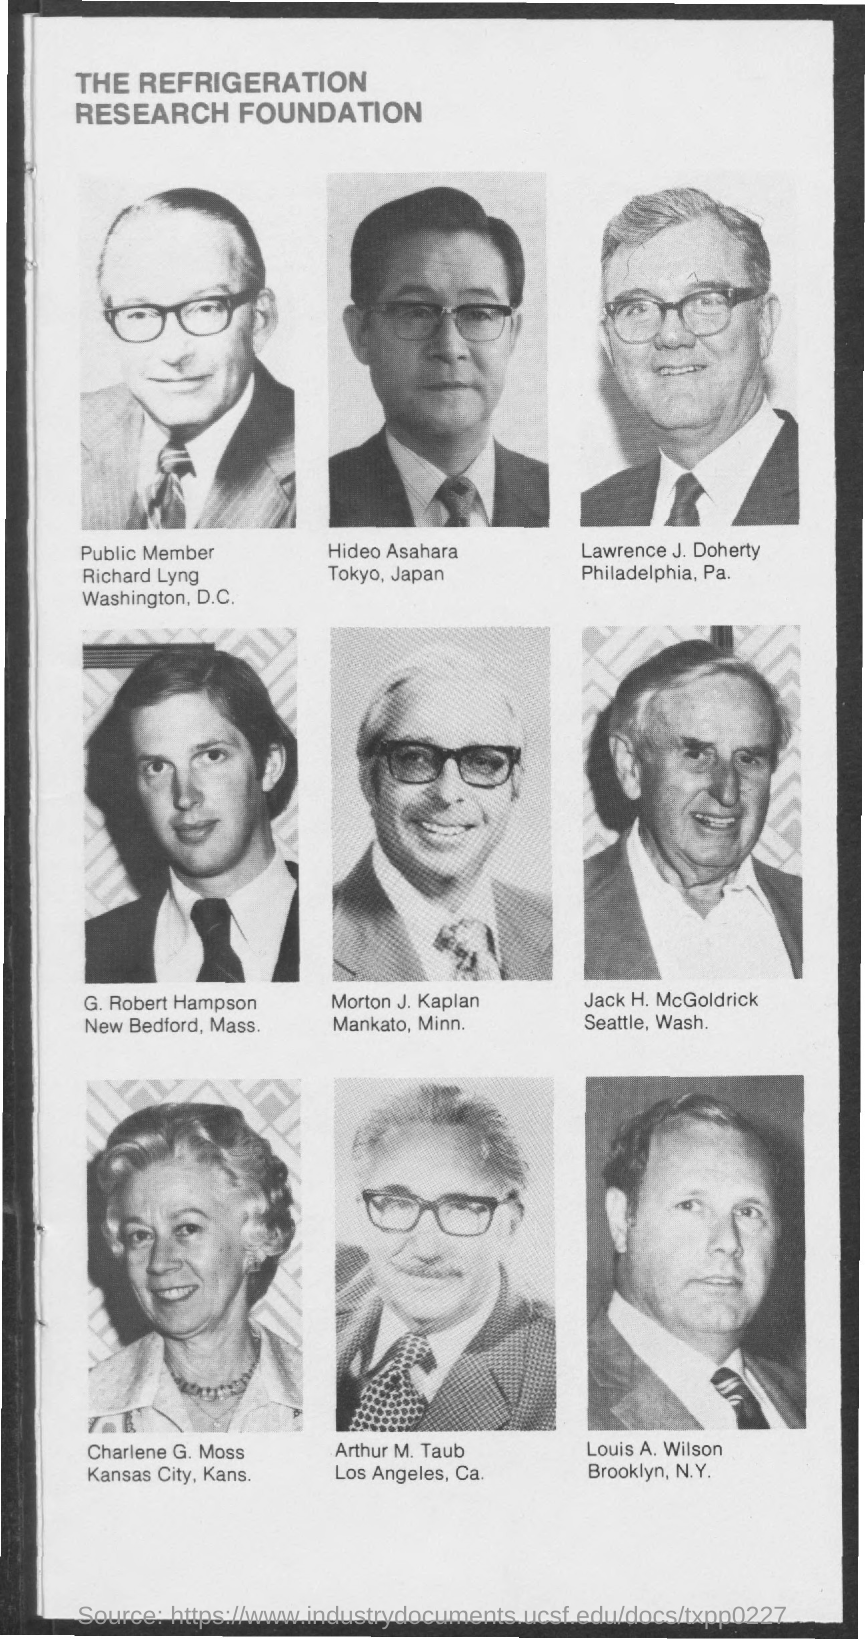What is the title of the document?
Offer a terse response. The refrigeration research foundation. 